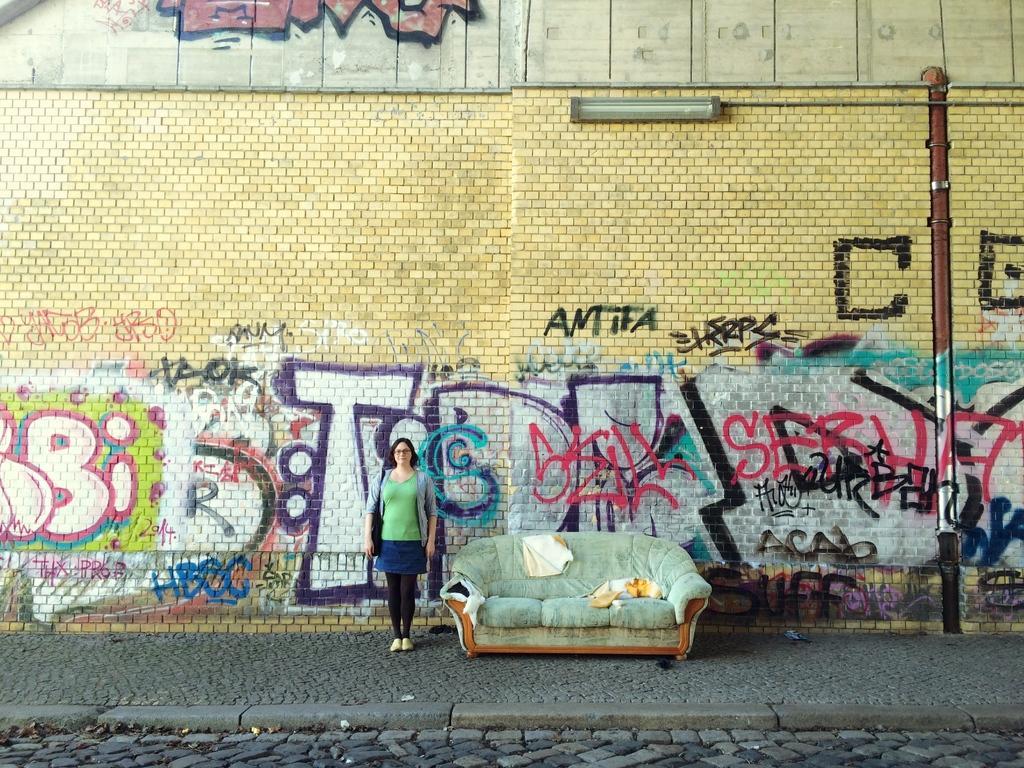Could you give a brief overview of what you see in this image? In this picture we can describe that a girl is standing on the pedestrian walking area, behind her a big wall with spray art design done and couch beside her. 